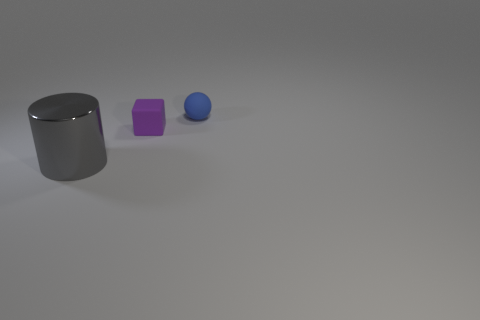Are there any other things that have the same material as the big object?
Make the answer very short. No. Are the cylinder and the purple object made of the same material?
Provide a succinct answer. No. How many blue objects are either tiny balls or metallic things?
Ensure brevity in your answer.  1. How many purple rubber objects have the same shape as the large gray thing?
Your answer should be very brief. 0. What material is the purple object?
Offer a very short reply. Rubber. Are there an equal number of large gray objects that are in front of the blue rubber sphere and matte balls?
Offer a very short reply. Yes. There is a object that is the same size as the purple matte cube; what shape is it?
Your response must be concise. Sphere. Are there any tiny matte things that are on the right side of the tiny matte thing that is in front of the matte sphere?
Your response must be concise. Yes. How many big things are either blue rubber balls or blocks?
Ensure brevity in your answer.  0. Are there any other gray cylinders that have the same size as the cylinder?
Your response must be concise. No. 